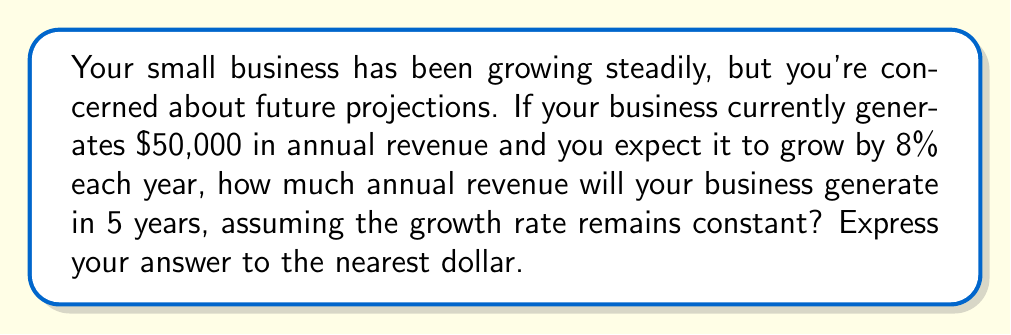Give your solution to this math problem. To solve this problem, we'll use an exponential function to model the business growth:

1) The general form of an exponential growth function is:
   $$A(t) = P(1 + r)^t$$
   Where:
   $A(t)$ is the amount after time $t$
   $P$ is the initial principal (starting amount)
   $r$ is the growth rate (as a decimal)
   $t$ is the time period

2) In this case:
   $P = 50000$ (initial revenue)
   $r = 0.08$ (8% growth rate)
   $t = 5$ (years)

3) Let's substitute these values into our equation:
   $$A(5) = 50000(1 + 0.08)^5$$

4) Simplify inside the parentheses:
   $$A(5) = 50000(1.08)^5$$

5) Calculate the exponent:
   $$A(5) = 50000 * 1.46933$$

6) Multiply:
   $$A(5) = 73466.50$$

7) Rounding to the nearest dollar:
   $$A(5) ≈ 73467$$

Therefore, in 5 years, your business is projected to generate approximately $73,467 in annual revenue.
Answer: $73,467 